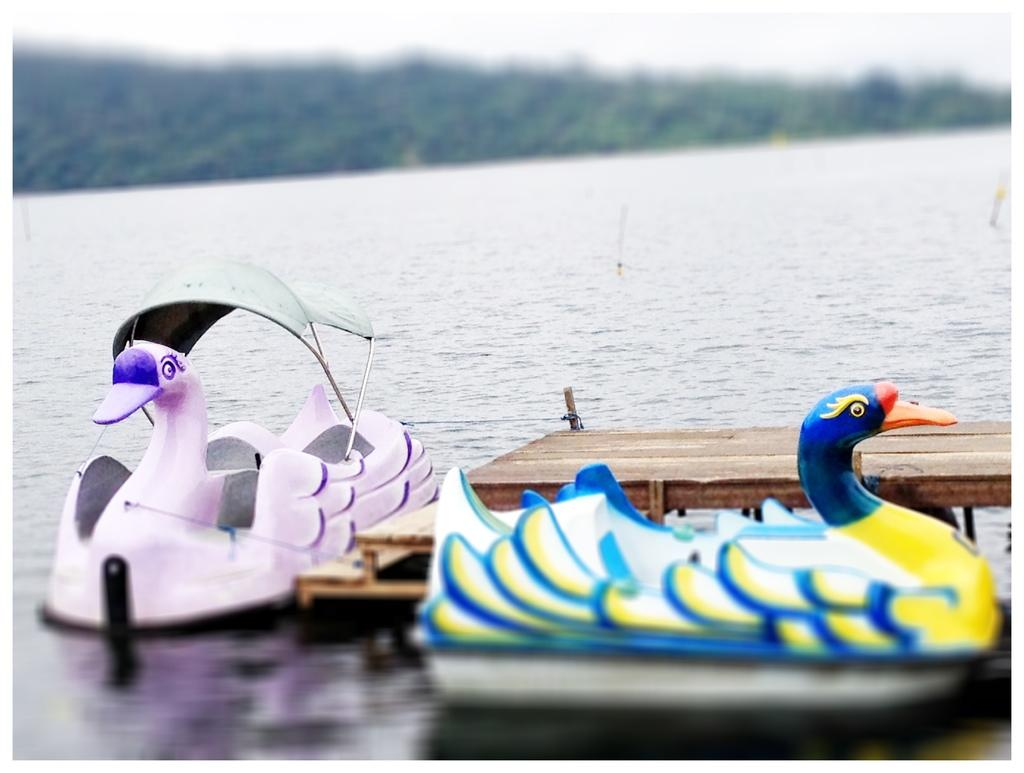What can be seen floating on the water in the image? There are two boats in the water. What is located near the boats? There is a wooden platform beside the boats. What can be seen in the background of the image? There are trees and the sky visible in the background of the image. What type of hair can be seen on the boats in the image? There is no hair present on the boats in the image; they are inanimate objects. 